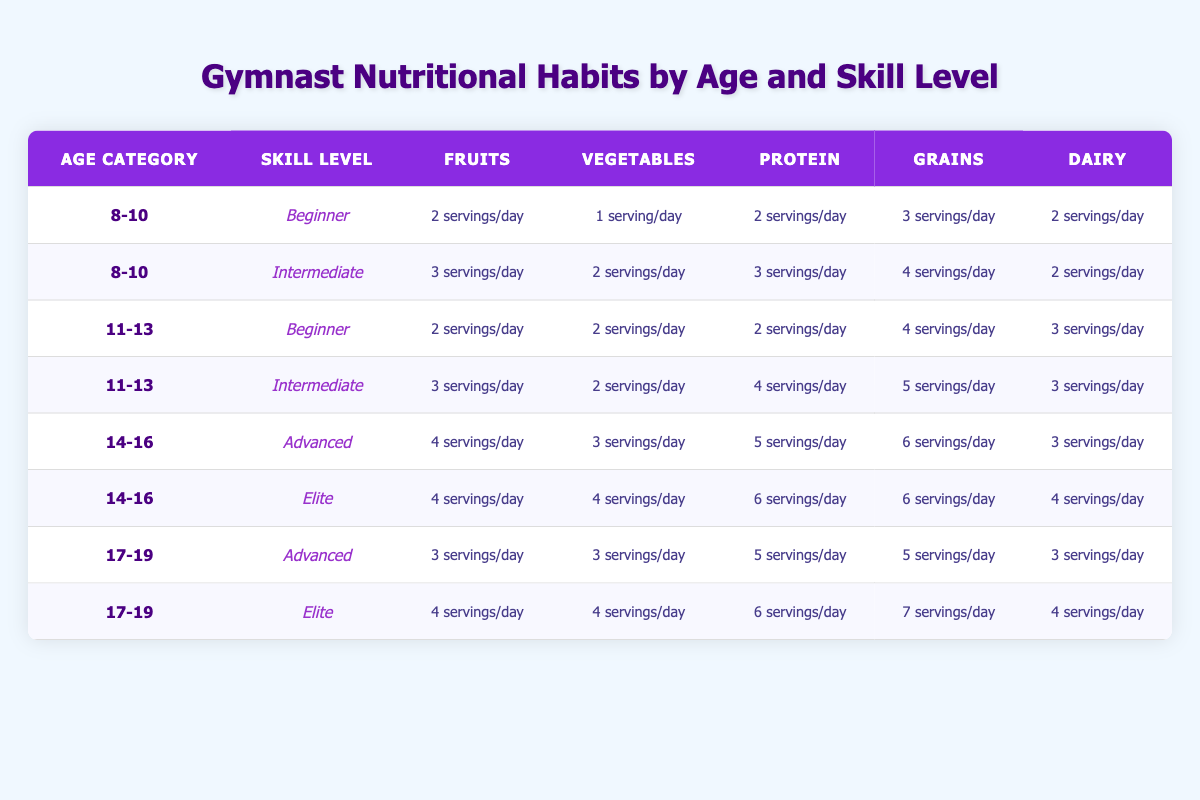What are the nutritional habits for the "11-13" age category skill level "Intermediate"? Referring to the table, for age category "11-13" and skill level "Intermediate," the nutritional habits are: Fruits: 3 servings/day, Vegetables: 2 servings/day, Protein: 4 servings/day, Grains: 5 servings/day, Dairy: 3 servings/day.
Answer: Fruits: 3 servings/day, Vegetables: 2 servings/day, Protein: 4 servings/day, Grains: 5 servings/day, Dairy: 3 servings/day Is the average number of servings of fruits higher among "Elite" gymnasts compared to "Beginner" gymnasts? To find the average for "Elite," we take the servings from both age categories: (4 + 4)/2 = 4 servings. For "Beginner," we take: (2 + 2)/2 = 2 servings. Since 4 is greater than 2, the average is higher for "Elite."
Answer: Yes Does the "14-16" age group have more servings of grains than the "8-10" age group? The "14-16" age group has 6 servings (Advanced: 6 & Elite: 6) while the "8-10" age group has 3 servings (Beginner: 3 & Intermediate: 4). Since 6 is greater than 3, it confirms that the "14-16" age group has more servings of grains.
Answer: Yes What is the total number of protein servings for "Advanced" gymnasts across all age categories? Advanced gymnasts' protein servings are: 5 servings (14-16) + 5 servings (17-19) = 10 servings in total.
Answer: 10 servings Are "Intermediate" gymnasts in the age group "11-13" eating more servings of vegetables than those in the age group "8-10"? The "Intermediate" gymnasts in "11-13" consume 2 servings of vegetables, while those in "8-10" consume 2 servings as well. Since both are equal, "Intermediate" gymnasts in both age categories consume the same amount of vegetables.
Answer: No For the age category "17-19," which skill level has the highest servings of dairy? In the "17-19" category, for Advanced: 3 servings and for Elite: 4 servings. The highest is therefore 4 servings from Elite gymnasts.
Answer: 4 servings What is the difference in the average servings of grains between "Beginner" and "Elite" skill levels? "Beginner" gymnasts have averages of (3 + 4) / 2 = 3.5 servings, while "Elite" gymnasts are at (6 + 6) / 2 = 6 servings. The difference is 6 - 3.5 = 2.5 servings.
Answer: 2.5 servings Are there more servings of vegetables for "Advanced" gymnasts compared to "Intermediate" gymnasts across all age categories? "Advanced" gymnasts have a total of 3 (14-16) + 3 (17-19) = 6 servings of vegetables, while "Intermediate" gymnasts have 2 (8-10) + 2 (11-13) = 4 servings. Since 6 is greater than 4, "Advanced" gymnasts consume more vegetables.
Answer: Yes 